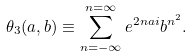<formula> <loc_0><loc_0><loc_500><loc_500>\theta _ { 3 } ( a , b ) \equiv \sum _ { n = - \infty } ^ { n = \infty } e ^ { 2 n a i } b ^ { n ^ { 2 } } .</formula> 